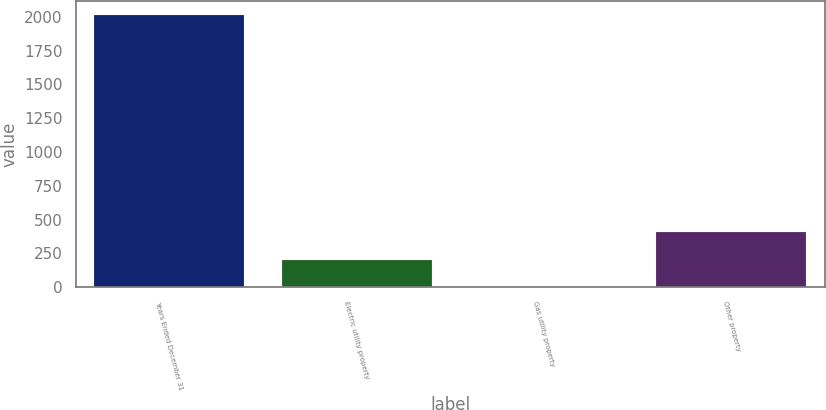Convert chart. <chart><loc_0><loc_0><loc_500><loc_500><bar_chart><fcel>Years Ended December 31<fcel>Electric utility property<fcel>Gas utility property<fcel>Other property<nl><fcel>2016<fcel>204.21<fcel>2.9<fcel>405.52<nl></chart> 